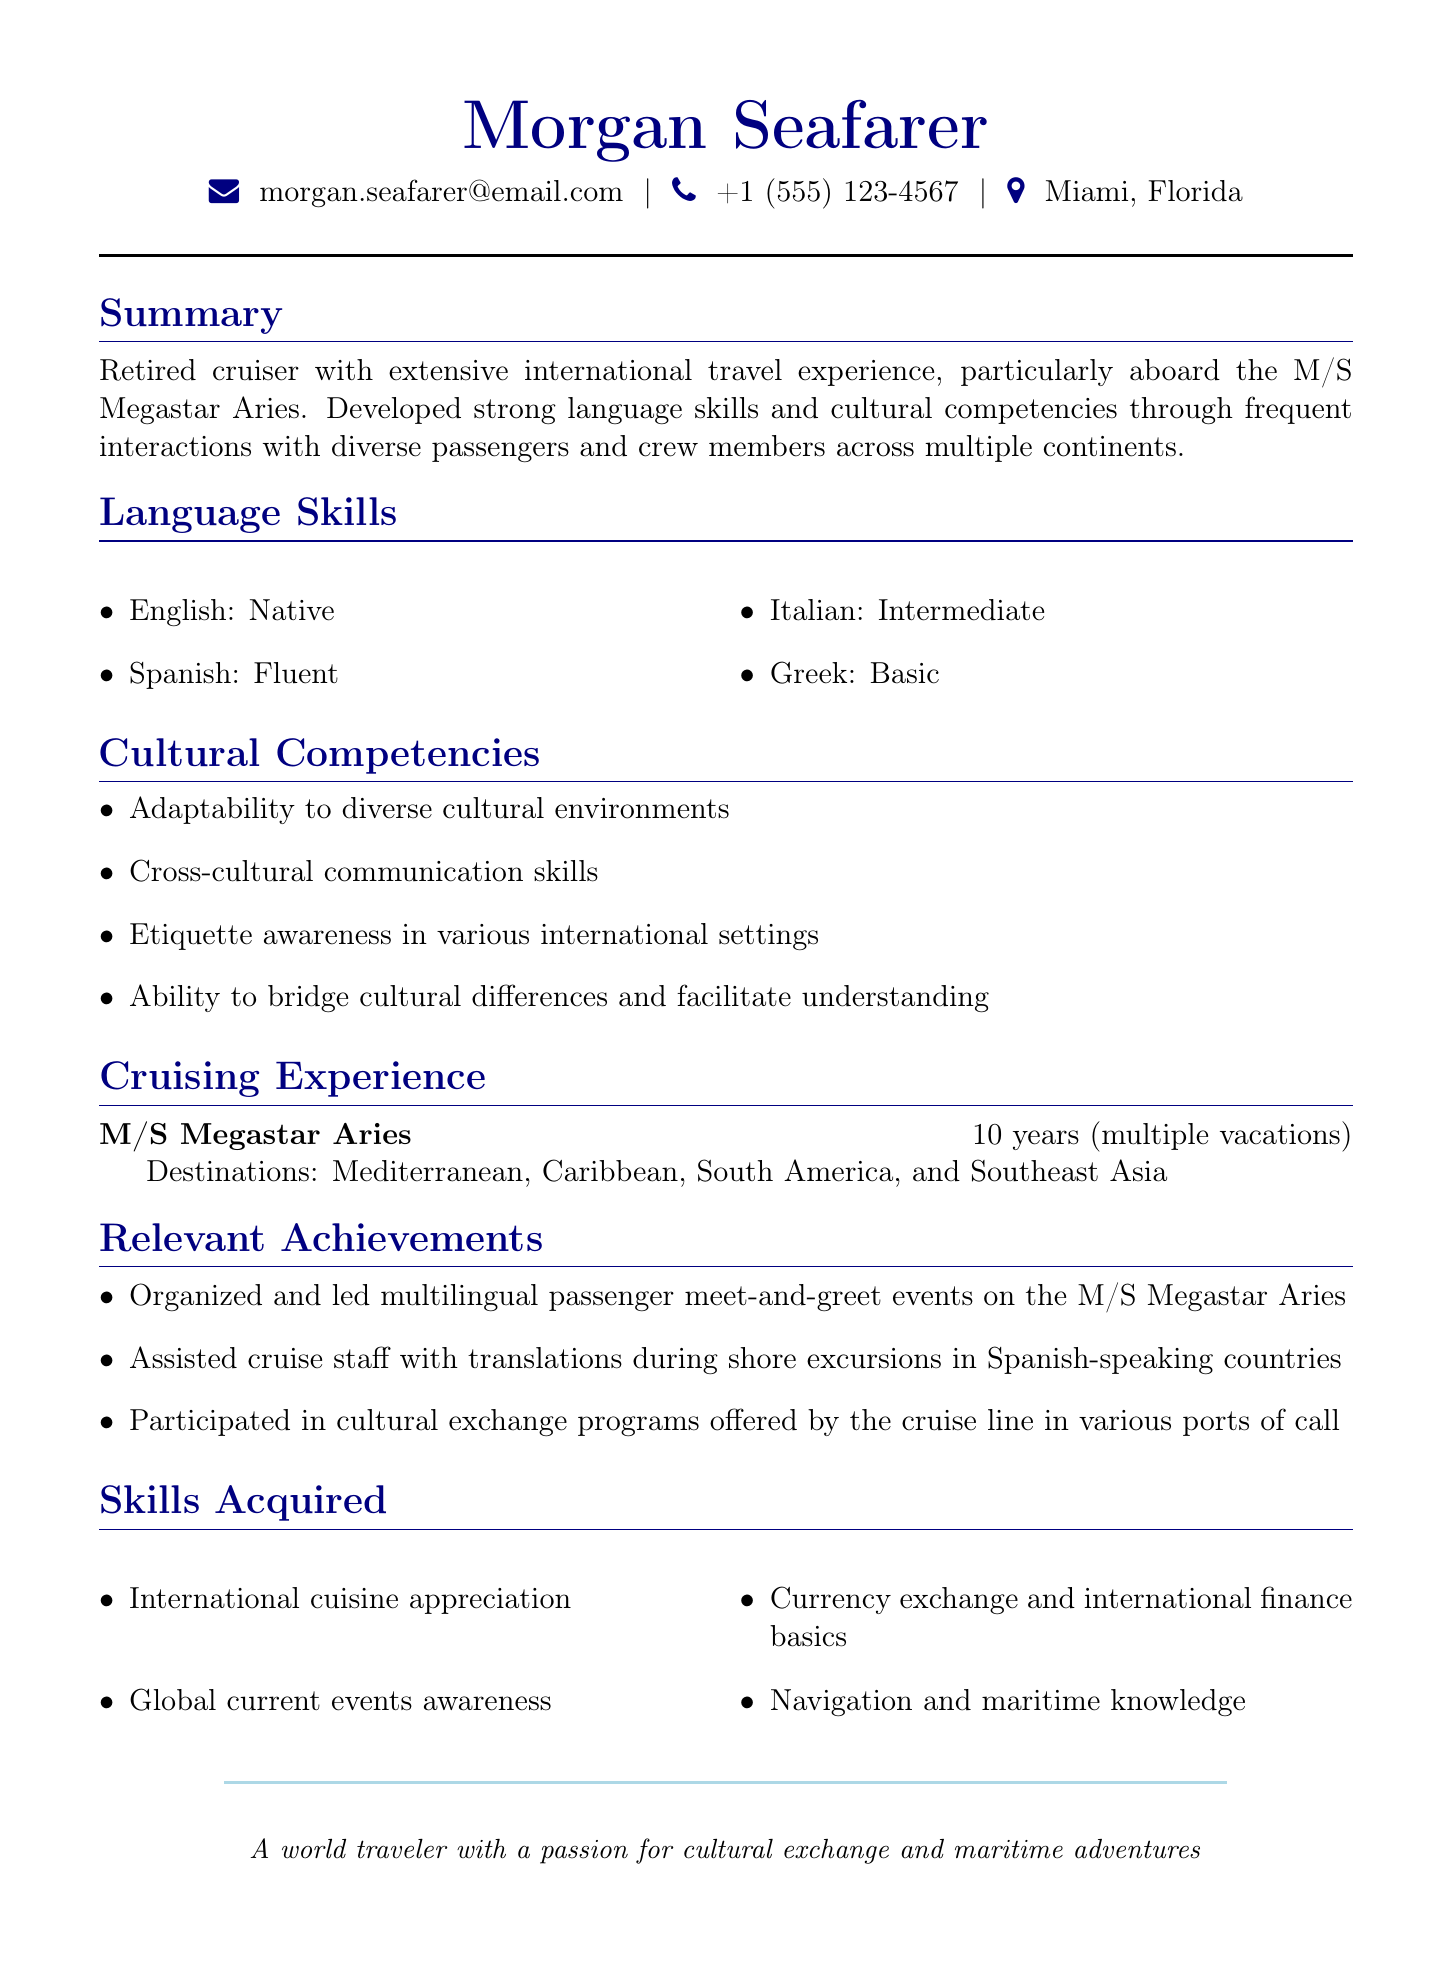What is the name of the individual in the resume? The name of the individual is provided at the top of the document.
Answer: Morgan Seafarer What is the duration of Morgan's cruising experience? The duration is mentioned in the "Cruising Experience" section of the document.
Answer: 10 years (multiple vacations) Which language is listed as fluent? Language proficiency levels are specifically identified in the "Language Skills" section.
Answer: Spanish What cultural competency involves communication skills? The "Cultural Competencies" section contains specific competencies.
Answer: Cross-cultural communication skills How many relevant achievements are listed in the resume? The number of achievements can be counted in the "Relevant Achievements" section.
Answer: 3 In which location does Morgan reside? The location is specified in the personal information at the beginning of the document.
Answer: Miami, Florida What basic language skill does Morgan have? The "Language Skills" section lists the languages and their proficiency levels.
Answer: Greek What region is notably mentioned among the cruise destinations? The destinations are outlined in the "Cruising Experience" section.
Answer: Mediterranean What skill involves awareness of international finance basics? The skills acquired are listed in the "Skills Acquired" section.
Answer: Currency exchange and international finance basics 